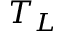<formula> <loc_0><loc_0><loc_500><loc_500>T _ { L }</formula> 